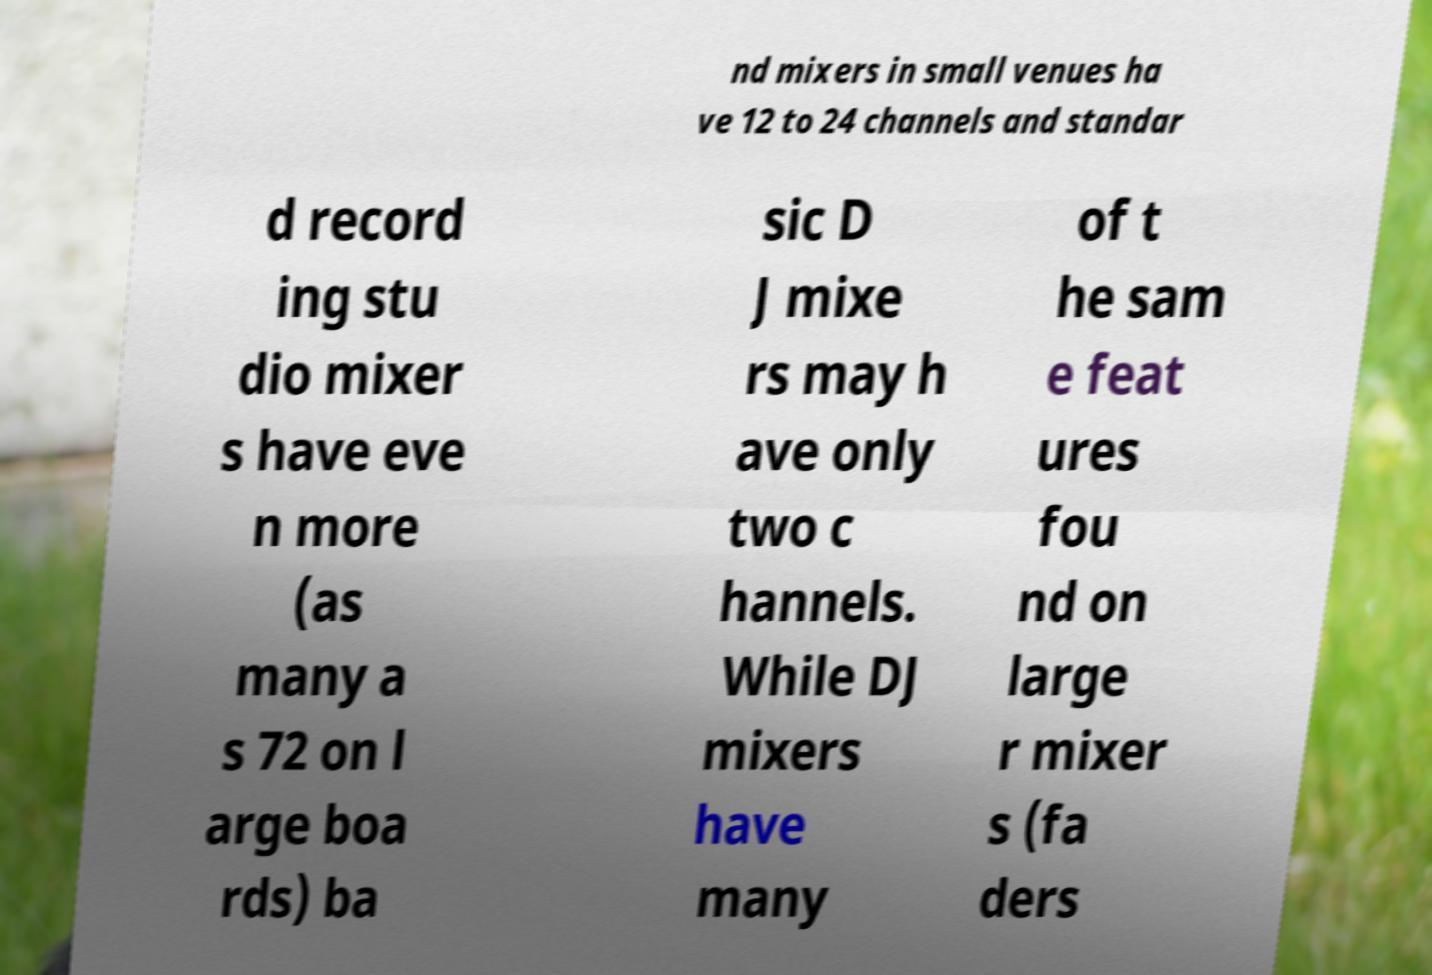Could you assist in decoding the text presented in this image and type it out clearly? nd mixers in small venues ha ve 12 to 24 channels and standar d record ing stu dio mixer s have eve n more (as many a s 72 on l arge boa rds) ba sic D J mixe rs may h ave only two c hannels. While DJ mixers have many of t he sam e feat ures fou nd on large r mixer s (fa ders 